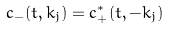Convert formula to latex. <formula><loc_0><loc_0><loc_500><loc_500>c _ { - } ( t , k _ { j } ) = c ^ { * } _ { + } ( t , - k _ { j } )</formula> 